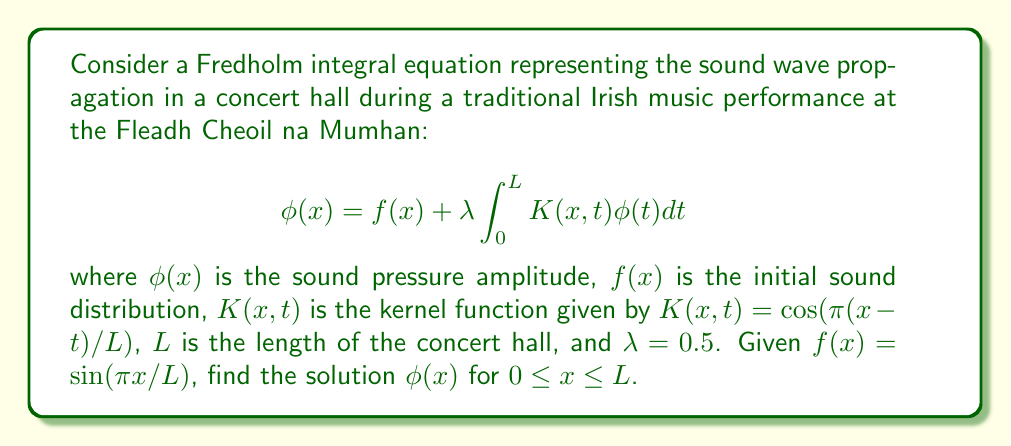What is the answer to this math problem? To solve this Fredholm integral equation, we'll use the method of successive approximations:

1) First, let's assume the solution has the form:
   $$ \phi(x) = A \sin(\pi x/L) $$
   where $A$ is a constant to be determined.

2) Substitute this into the integral equation:
   $$ A \sin(\pi x/L) = \sin(\pi x/L) + 0.5 \int_0^L \cos(\pi(x-t)/L) \cdot A \sin(\pi t/L)dt $$

3) Simplify the right-hand side using trigonometric identities:
   $$ \int_0^L \cos(\pi(x-t)/L) \sin(\pi t/L)dt = \frac{L}{2}\sin(\pi x/L) $$

4) Now our equation becomes:
   $$ A \sin(\pi x/L) = \sin(\pi x/L) + 0.5 \cdot \frac{L}{2} \cdot A \sin(\pi x/L) $$
   $$ A \sin(\pi x/L) = \sin(\pi x/L) + 0.25L \cdot A \sin(\pi x/L) $$

5) Equating coefficients of $\sin(\pi x/L)$:
   $$ A = 1 + 0.25L \cdot A $$

6) Solve for $A$:
   $$ A - 0.25L \cdot A = 1 $$
   $$ A(1 - 0.25L) = 1 $$
   $$ A = \frac{1}{1 - 0.25L} $$

Therefore, the solution is:
$$ \phi(x) = \frac{1}{1 - 0.25L} \sin(\pi x/L) $$
Answer: $\phi(x) = \frac{1}{1 - 0.25L} \sin(\pi x/L)$ 